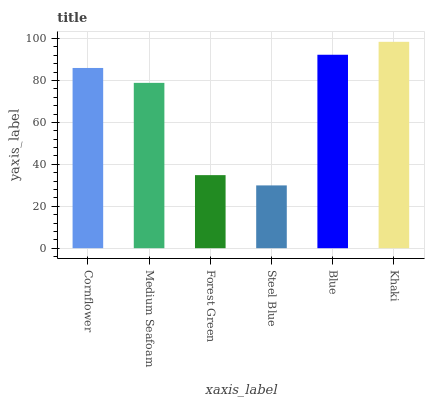Is Steel Blue the minimum?
Answer yes or no. Yes. Is Khaki the maximum?
Answer yes or no. Yes. Is Medium Seafoam the minimum?
Answer yes or no. No. Is Medium Seafoam the maximum?
Answer yes or no. No. Is Cornflower greater than Medium Seafoam?
Answer yes or no. Yes. Is Medium Seafoam less than Cornflower?
Answer yes or no. Yes. Is Medium Seafoam greater than Cornflower?
Answer yes or no. No. Is Cornflower less than Medium Seafoam?
Answer yes or no. No. Is Cornflower the high median?
Answer yes or no. Yes. Is Medium Seafoam the low median?
Answer yes or no. Yes. Is Blue the high median?
Answer yes or no. No. Is Blue the low median?
Answer yes or no. No. 